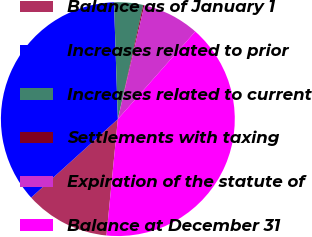<chart> <loc_0><loc_0><loc_500><loc_500><pie_chart><fcel>Balance as of January 1<fcel>Increases related to prior<fcel>Increases related to current<fcel>Settlements with taxing<fcel>Expiration of the statute of<fcel>Balance at December 31<nl><fcel>11.74%<fcel>36.18%<fcel>4.01%<fcel>0.15%<fcel>7.88%<fcel>40.04%<nl></chart> 